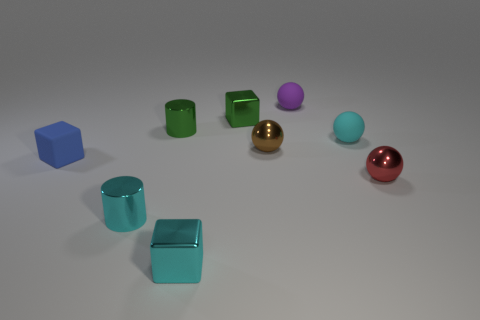What number of cylinders are either green objects or small blue rubber things? In the image, there are two green cylindrical objects and one small blue cube, which is not a cylinder. Therefore, the total number of cylinders that are either green or small blue rubber things is two. 